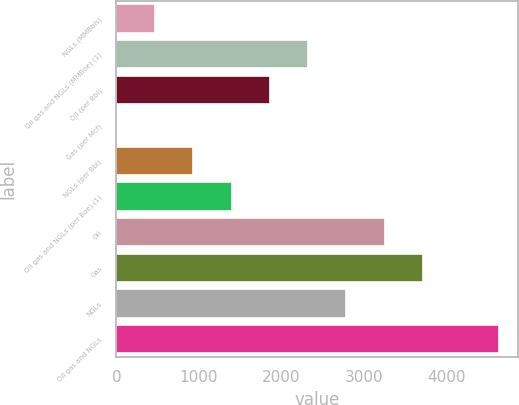Convert chart to OTSL. <chart><loc_0><loc_0><loc_500><loc_500><bar_chart><fcel>NGLs (MMBbls)<fcel>Oil gas and NGLs (MMBoe) (1)<fcel>Oil (per Bbl)<fcel>Gas (per Mcf)<fcel>NGLs (per Bbl)<fcel>Oil gas and NGLs (per Boe) (1)<fcel>Oil<fcel>Gas<fcel>NGLs<fcel>Oil gas and NGLs<nl><fcel>469.09<fcel>2323.73<fcel>1860.07<fcel>5.43<fcel>932.75<fcel>1396.41<fcel>3251.05<fcel>3714.71<fcel>2787.39<fcel>4642<nl></chart> 